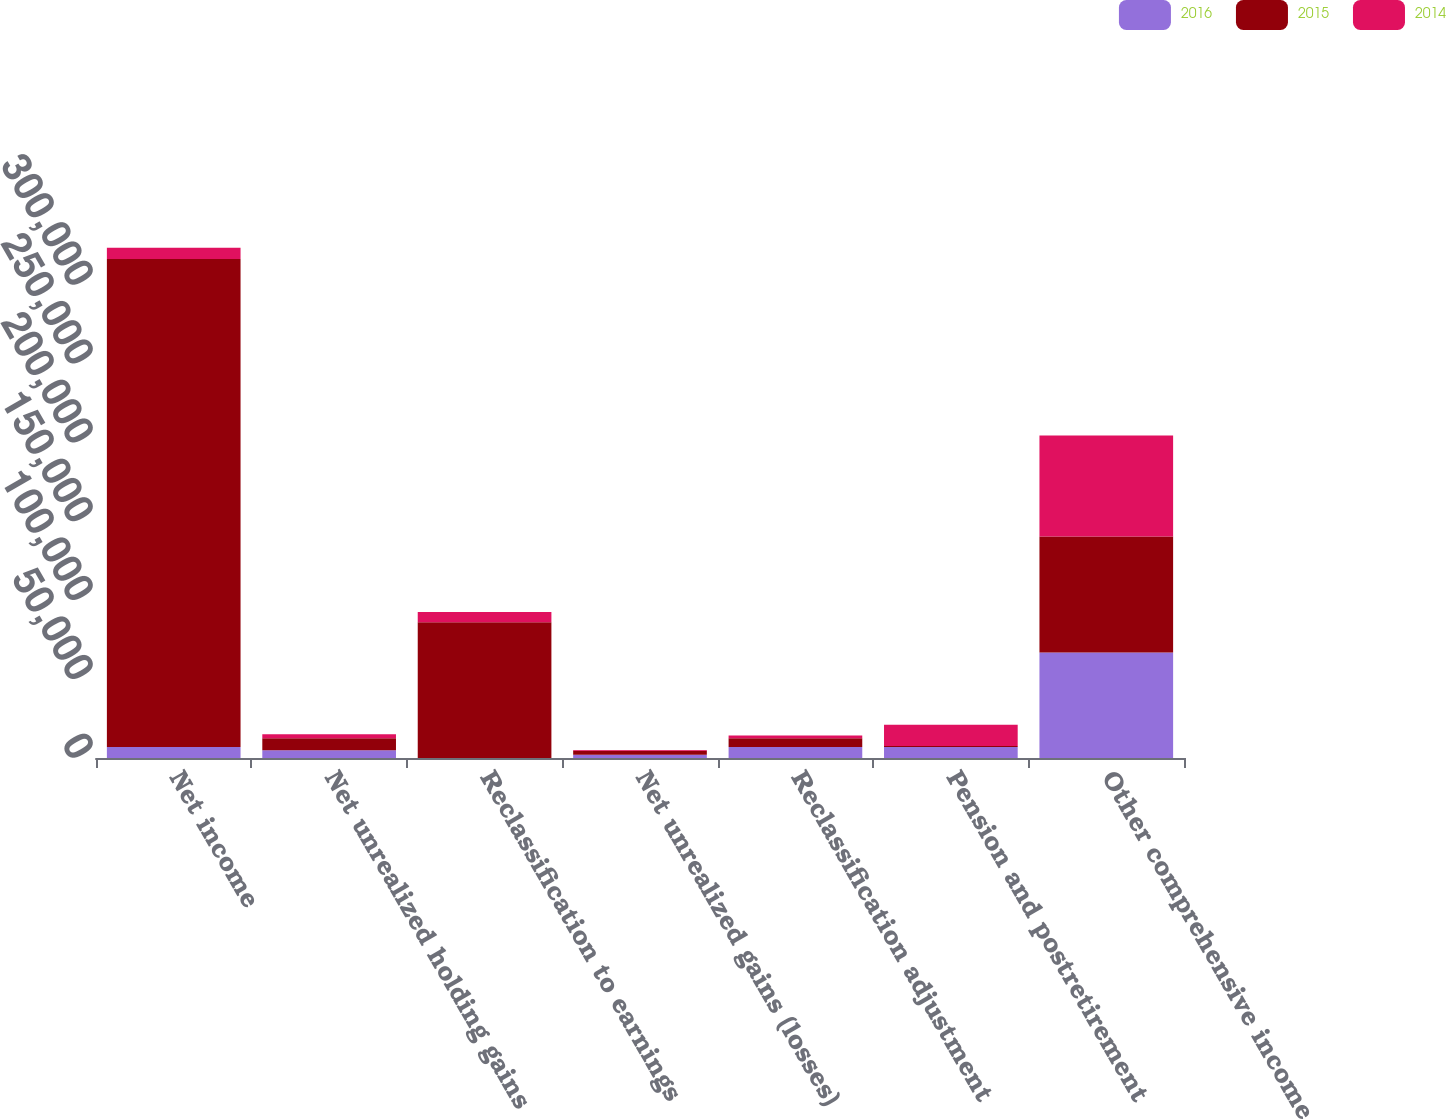Convert chart. <chart><loc_0><loc_0><loc_500><loc_500><stacked_bar_chart><ecel><fcel>Net income<fcel>Net unrealized holding gains<fcel>Reclassification to earnings<fcel>Net unrealized gains (losses)<fcel>Reclassification adjustment<fcel>Pension and postretirement<fcel>Other comprehensive income<nl><fcel>2016<fcel>6993<fcel>4993<fcel>63<fcel>2100<fcel>7000<fcel>6986<fcel>66969<nl><fcel>2015<fcel>309471<fcel>7455<fcel>86023<fcel>2552<fcel>5583<fcel>557<fcel>73429<nl><fcel>2014<fcel>6993<fcel>2664<fcel>6447<fcel>390<fcel>1605<fcel>13494<fcel>64060<nl></chart> 